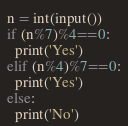<code> <loc_0><loc_0><loc_500><loc_500><_Python_>n = int(input())
if (n%7)%4==0:
  print('Yes')
elif (n%4)%7==0:
  print('Yes')
else:
  print('No')
</code> 